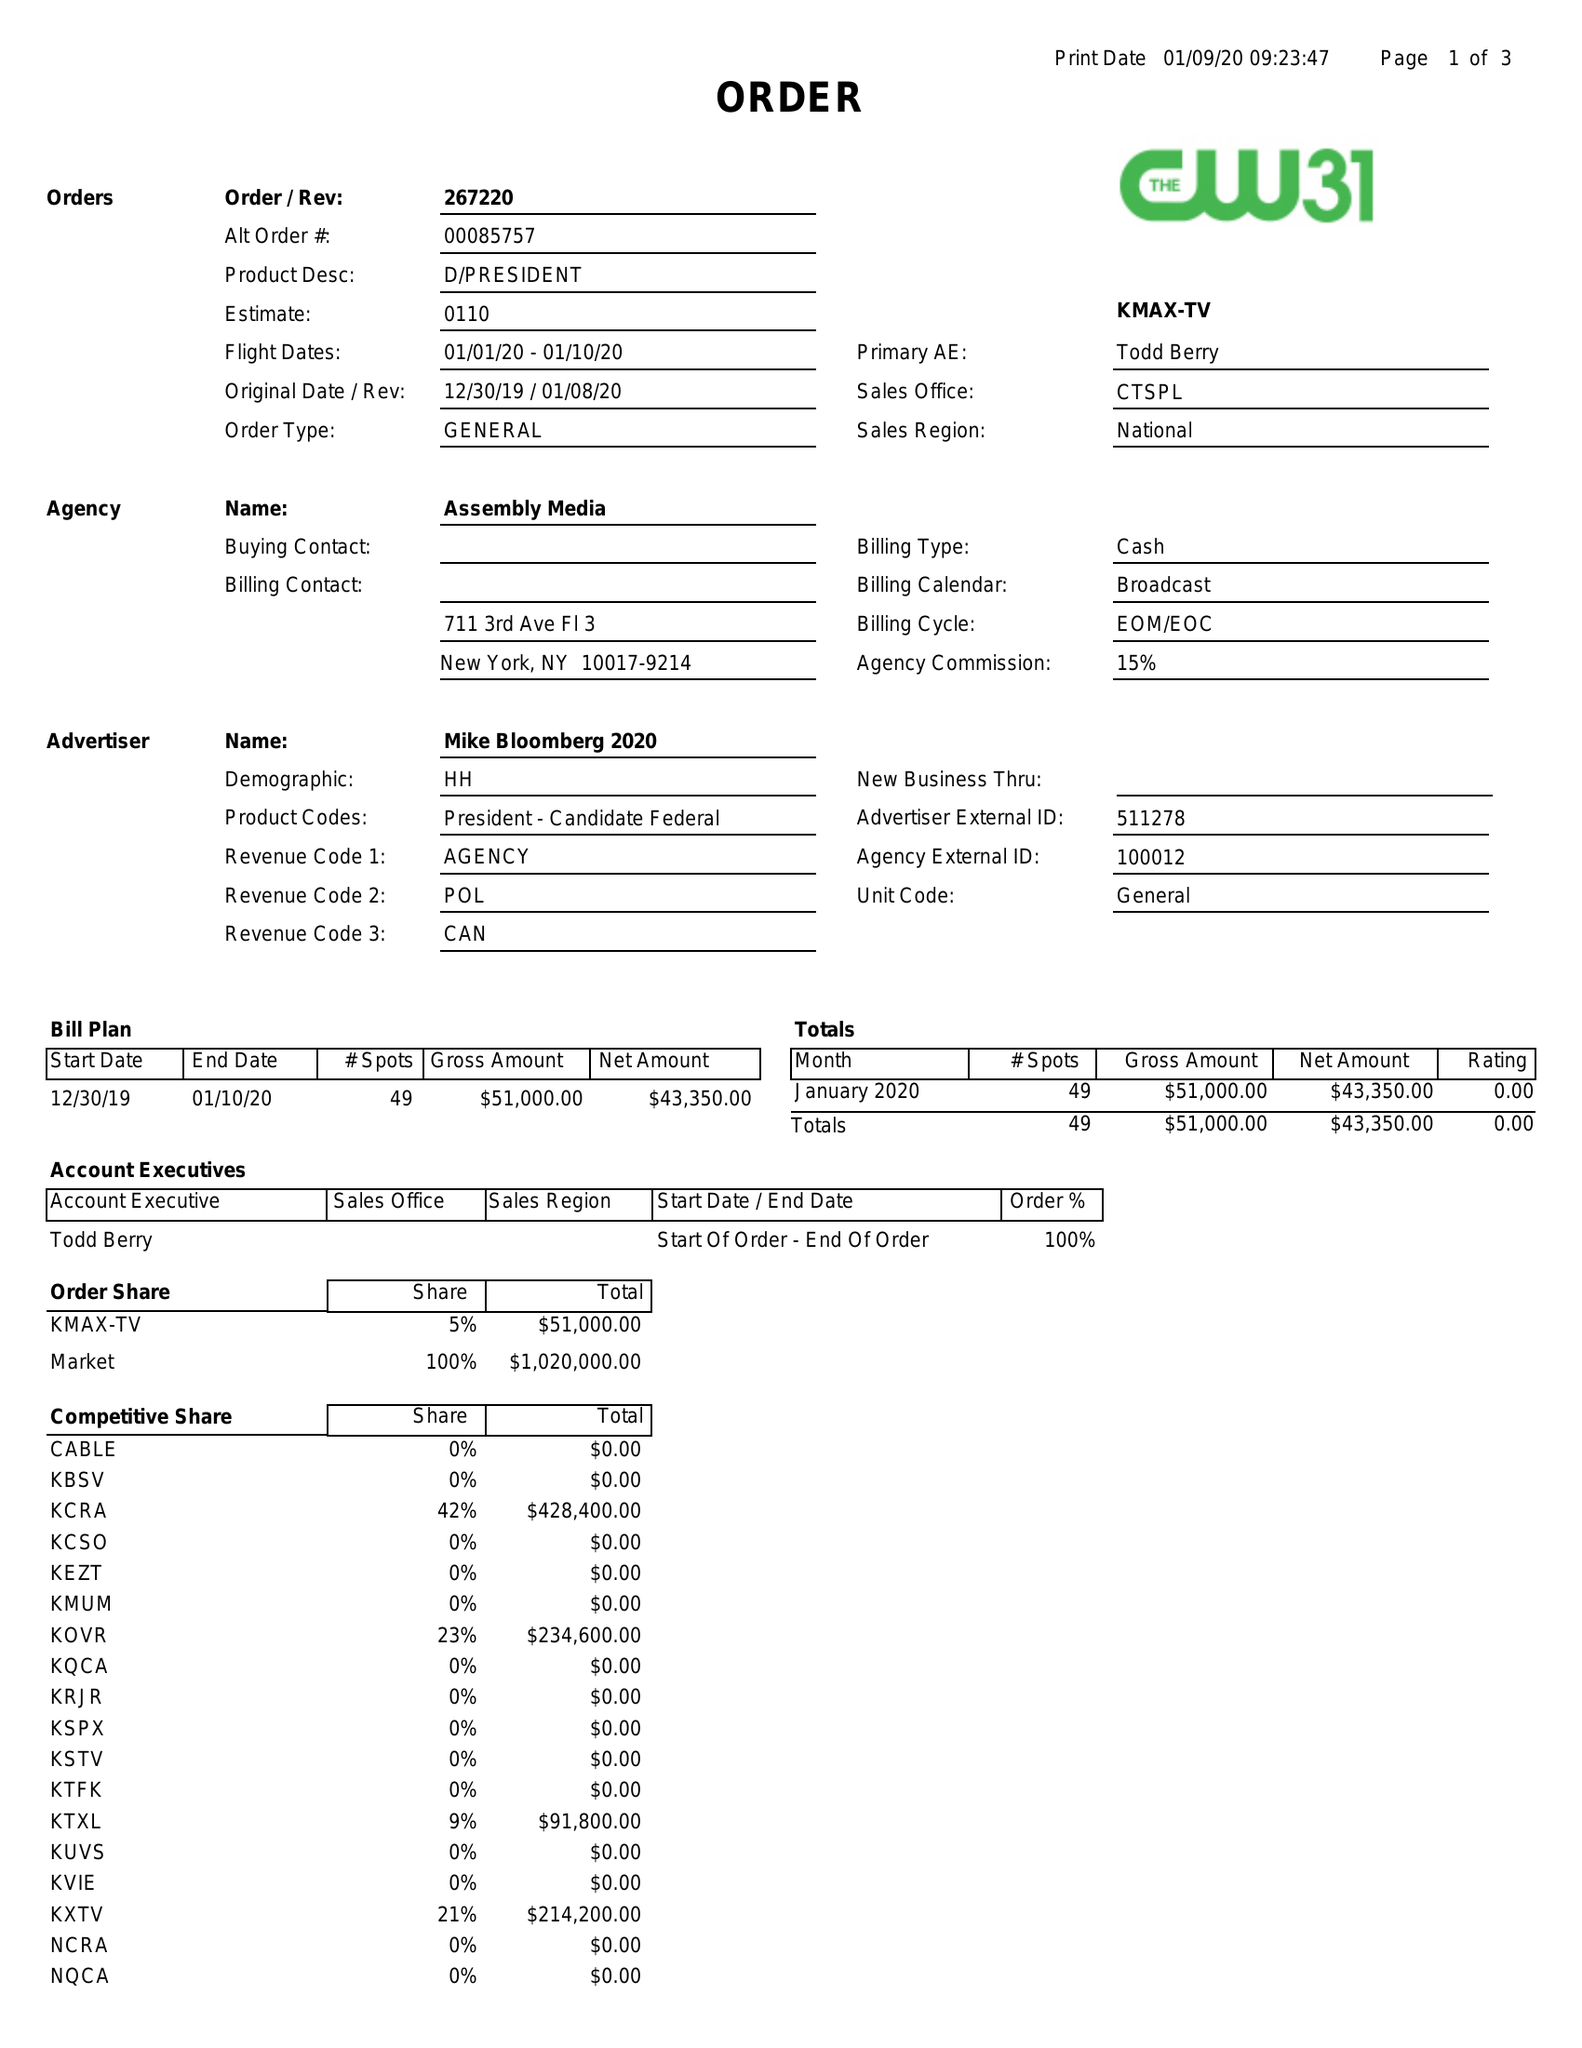What is the value for the flight_to?
Answer the question using a single word or phrase. 01/10/20 